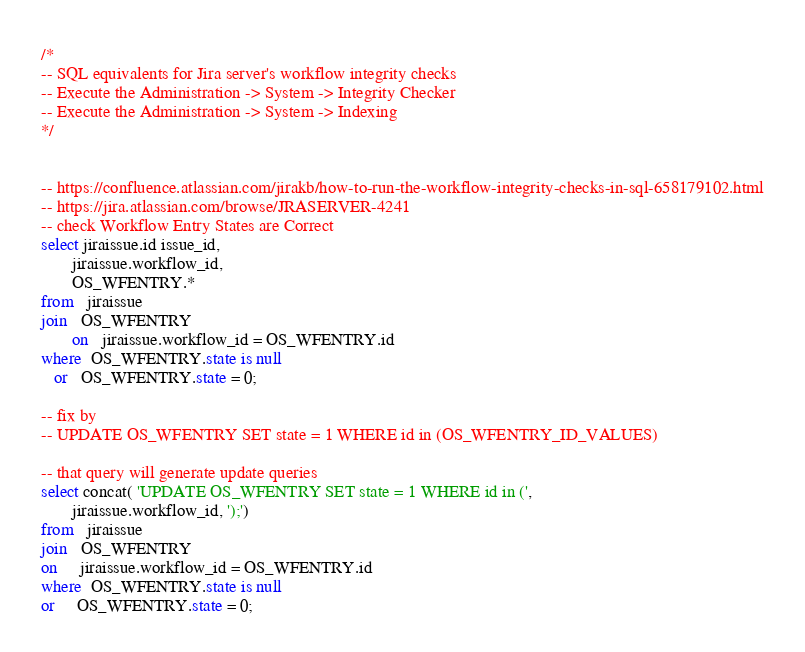Convert code to text. <code><loc_0><loc_0><loc_500><loc_500><_SQL_>/*
-- SQL equivalents for Jira server's workflow integrity checks
-- Execute the Administration -> System -> Integrity Checker
-- Execute the Administration -> System -> Indexing
*/


-- https://confluence.atlassian.com/jirakb/how-to-run-the-workflow-integrity-checks-in-sql-658179102.html
-- https://jira.atlassian.com/browse/JRASERVER-4241
-- check Workflow Entry States are Correct
select jiraissue.id issue_id,
       jiraissue.workflow_id,
       OS_WFENTRY.*
from   jiraissue
join   OS_WFENTRY
       on   jiraissue.workflow_id = OS_WFENTRY.id
where  OS_WFENTRY.state is null
   or   OS_WFENTRY.state = 0;

-- fix by
-- UPDATE OS_WFENTRY SET state = 1 WHERE id in (OS_WFENTRY_ID_VALUES)

-- that query will generate update queries
select concat( 'UPDATE OS_WFENTRY SET state = 1 WHERE id in (',
       jiraissue.workflow_id, ');')
from   jiraissue
join   OS_WFENTRY
on     jiraissue.workflow_id = OS_WFENTRY.id
where  OS_WFENTRY.state is null
or     OS_WFENTRY.state = 0;
</code> 